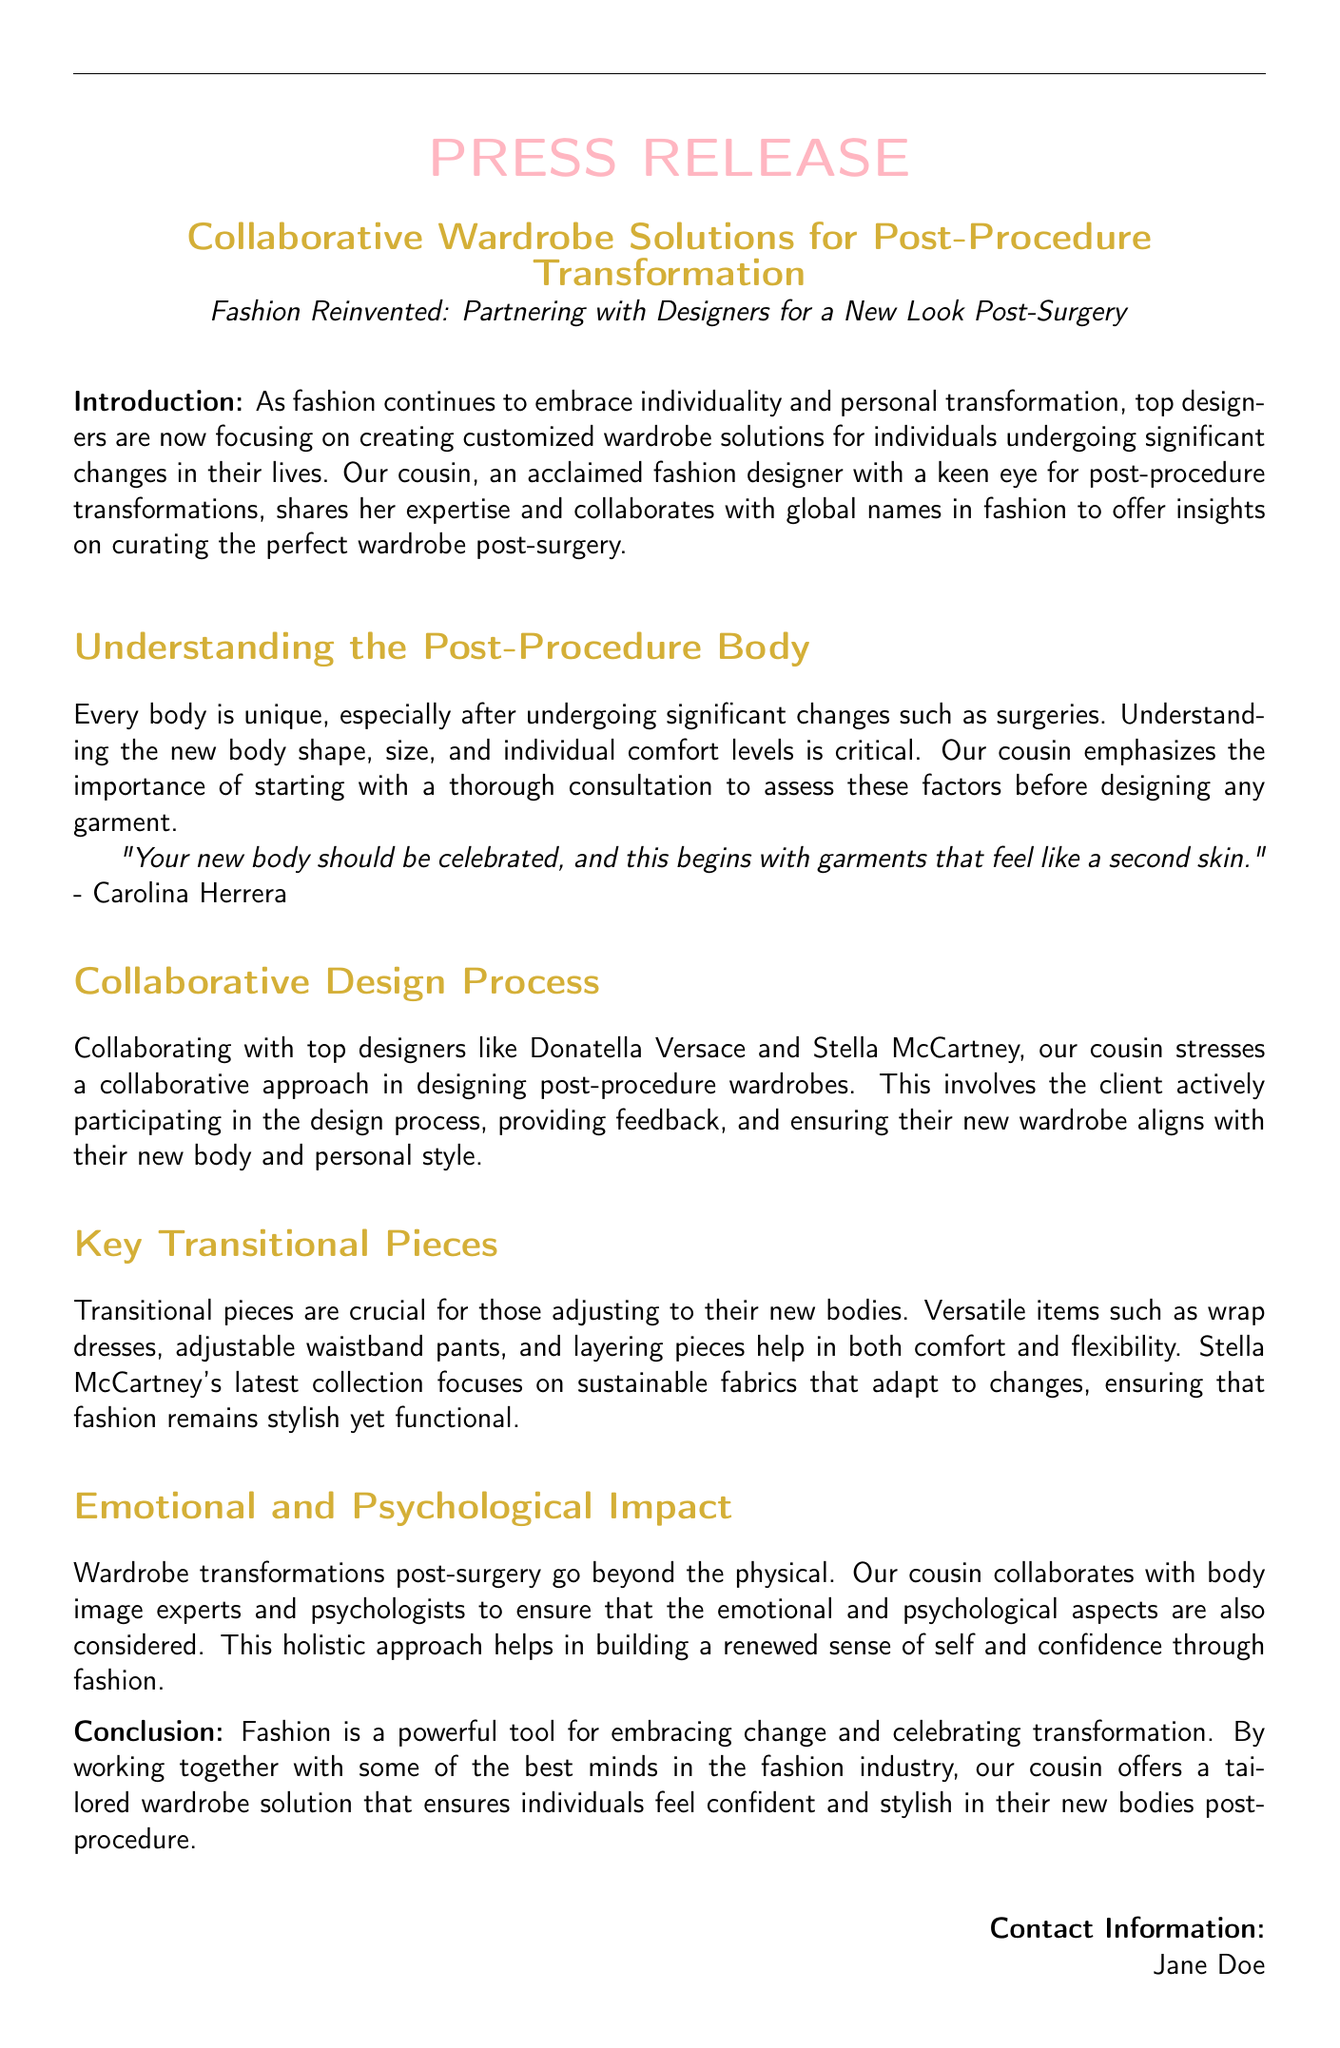What is the title of the press release? The title is bolded and is a key component of the document, indicating the main subject matter.
Answer: Collaborative Wardrobe Solutions for Post-Procedure Transformation Who is the acclaimed fashion designer mentioned in the document? The document highlights our cousin as the main designer providing insights and expertise.
Answer: our cousin Which top designers are collaborated with in the wardrobe solutions? The document lists specific designers involved in the collaborative wardrobe initiatives.
Answer: Donatella Versace and Stella McCartney What is a key transitional piece mentioned in the press release? Transitional pieces are essential for those adapting to their new bodies, and examples are provided.
Answer: wrap dresses What aspect does the collaborative approach in design emphasize? The document explains the importance of client involvement in the design process for contemporary wardrobes.
Answer: client participation Which psychological elements are considered in the post-surgery wardrobe transformation? The document includes a mention of psychological aspects to emphasize a holistic approach in the design process.
Answer: emotional and psychological impact 